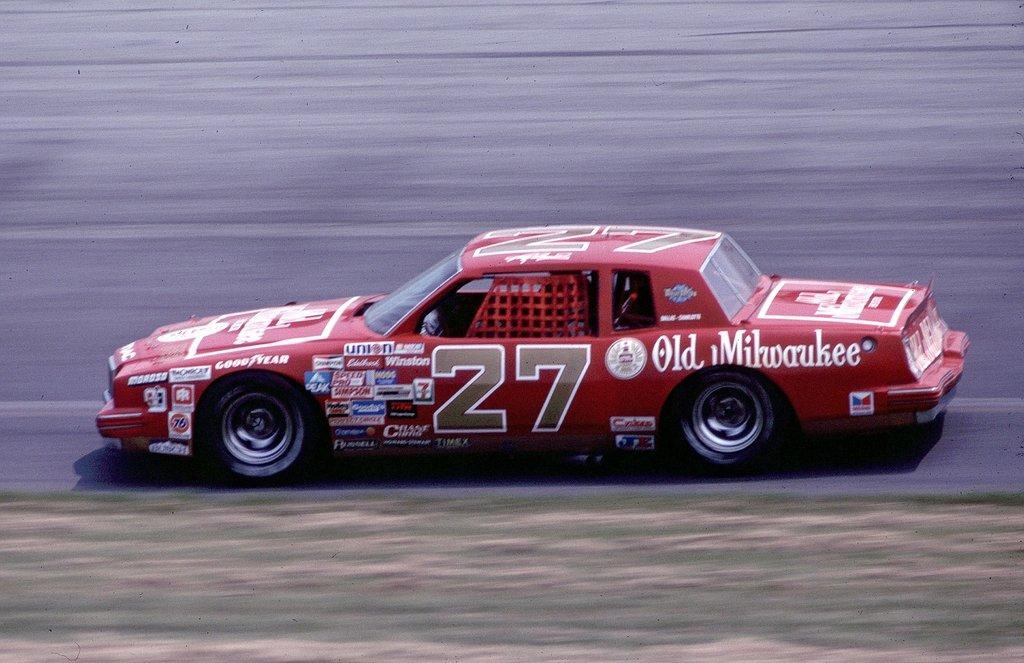Can you describe this image briefly? In this image we can see a red color car is moving on the road. 